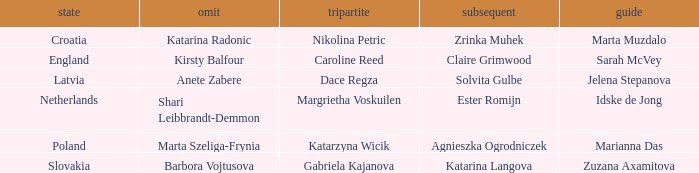What is the name of the second who has Caroline Reed as third? Claire Grimwood. 